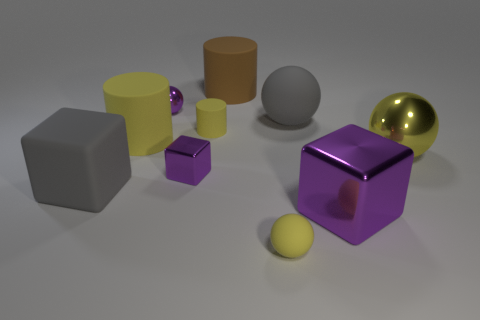Subtract all gray balls. How many yellow cylinders are left? 2 Subtract all yellow rubber balls. How many balls are left? 3 Subtract 1 cylinders. How many cylinders are left? 2 Subtract all purple balls. How many balls are left? 3 Subtract all green balls. Subtract all blue cubes. How many balls are left? 4 Subtract all spheres. How many objects are left? 6 Subtract all small red cylinders. Subtract all brown cylinders. How many objects are left? 9 Add 4 tiny blocks. How many tiny blocks are left? 5 Add 8 big gray shiny cubes. How many big gray shiny cubes exist? 8 Subtract 0 brown spheres. How many objects are left? 10 